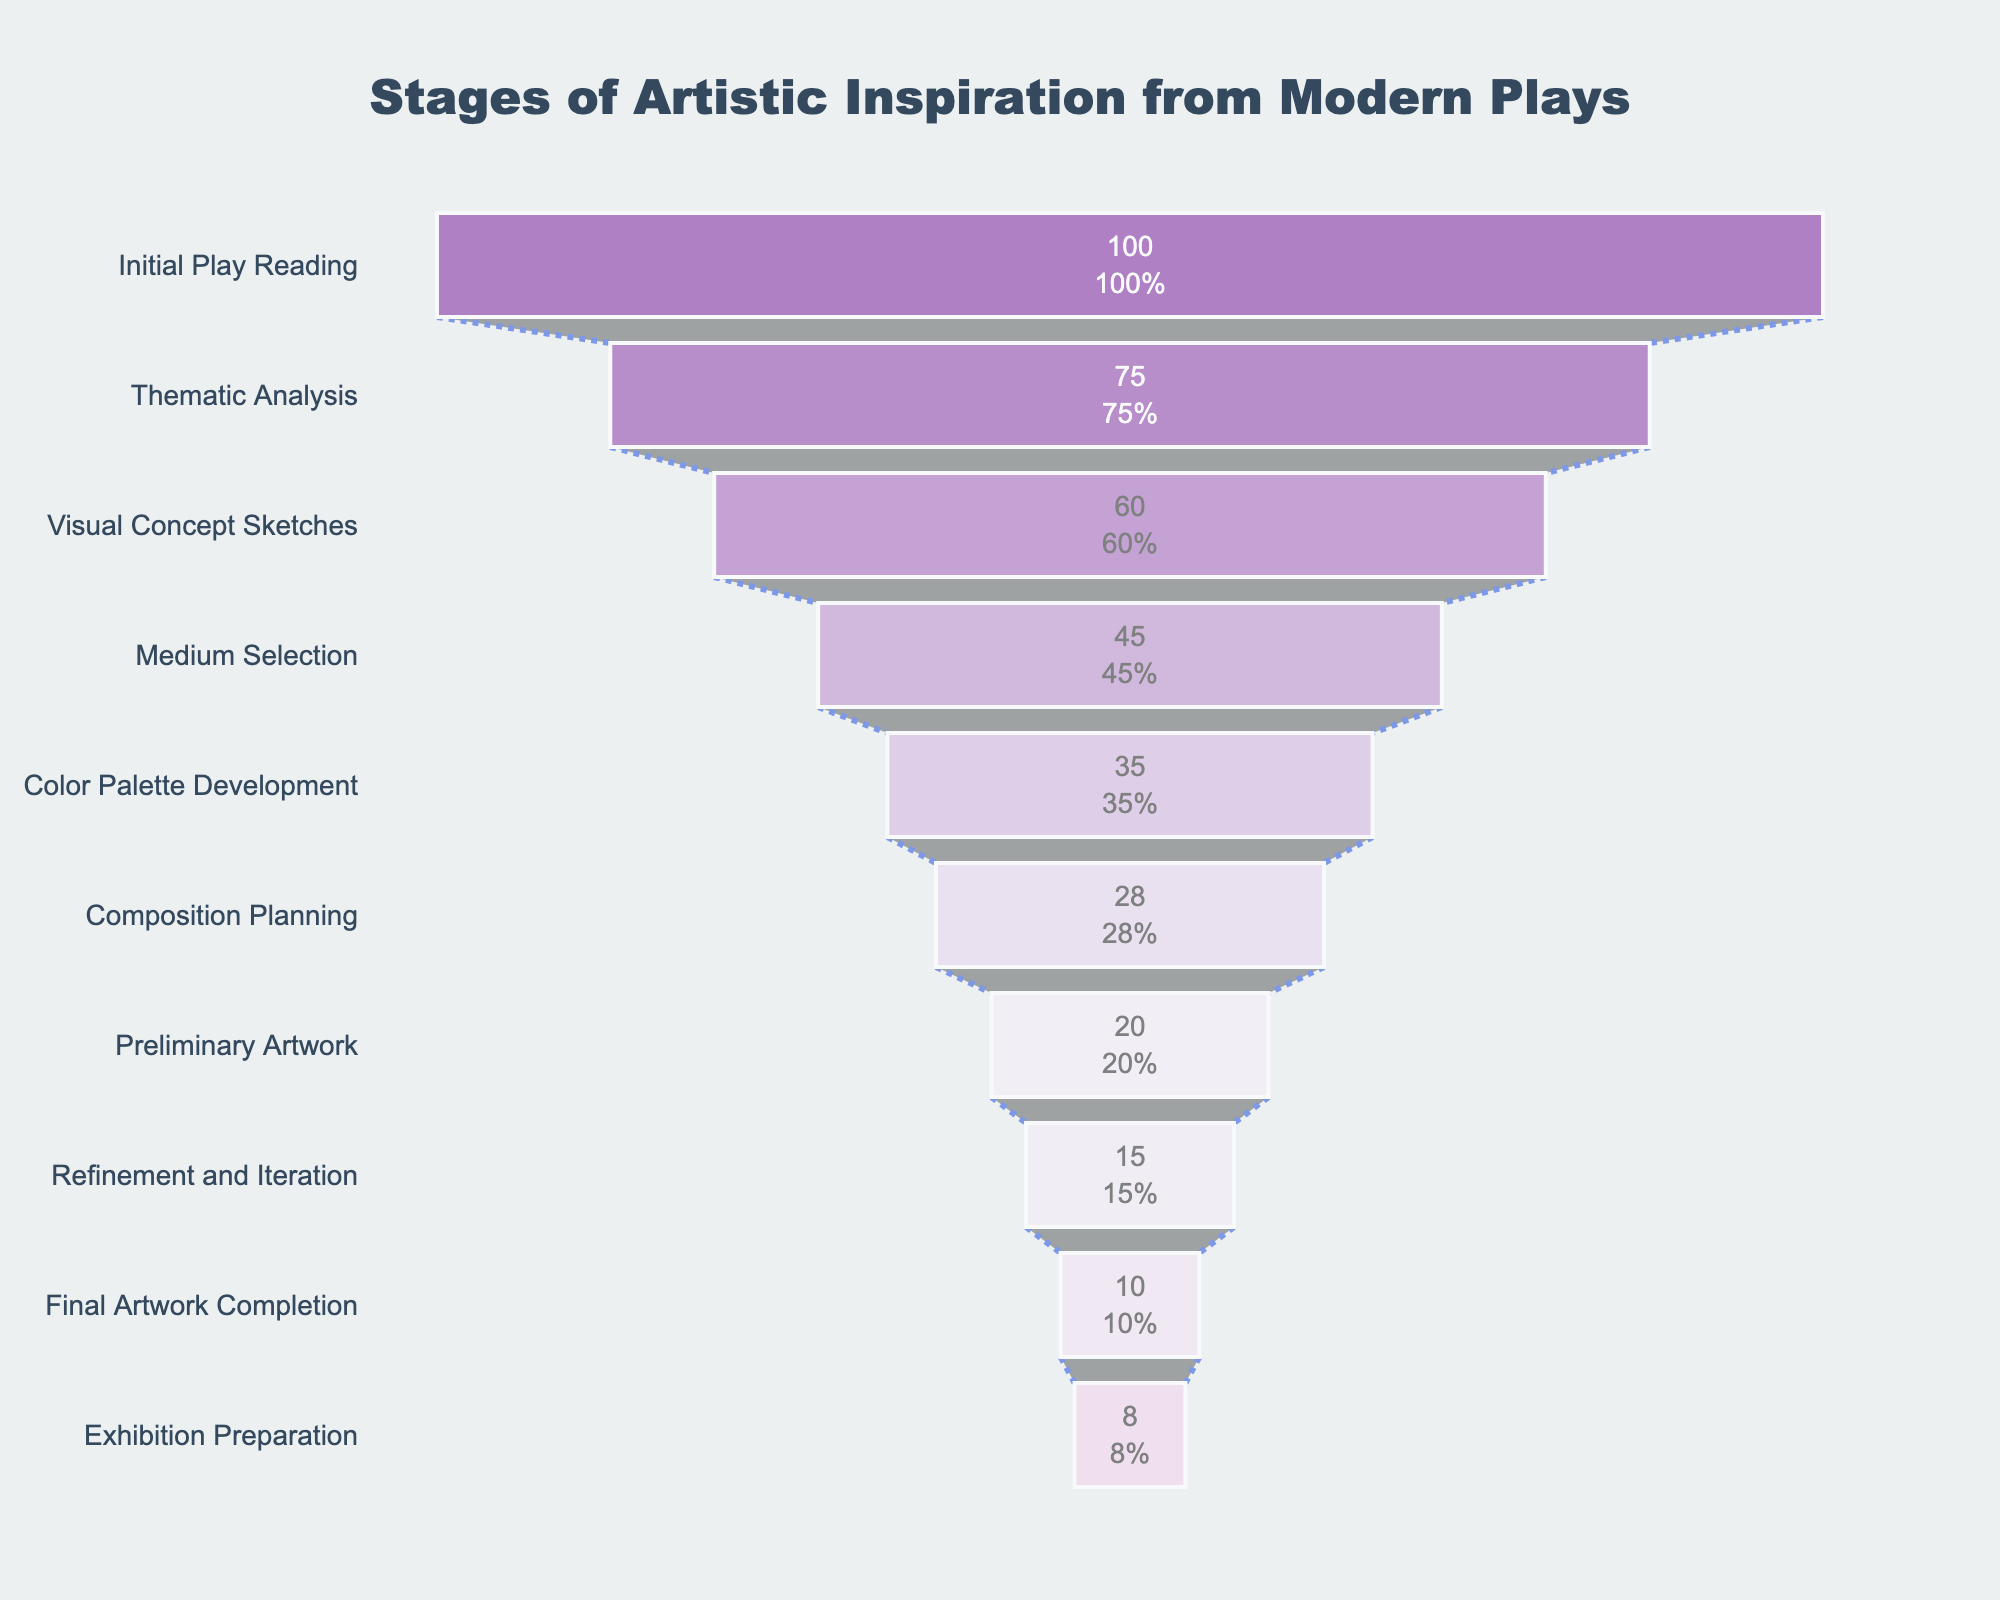What's the title of the figure? The title of a chart is typically found at the top and in larger font than the rest of the text. In this case, it's a descriptive title indicating what the chart is about.
Answer: Stages of Artistic Inspiration from Modern Plays How many stages are illustrated in the funnel chart? To find the number of stages, count the distinct stages listed along the vertical axis of the funnel. Each stage corresponds to one row in the data.
Answer: 10 What is the color assigned to the 'Thematic Analysis' stage? Each stage is colored differently. 'Thematic Analysis' corresponds to the second row in the data and is color-coded. We can identify its color from the chart's color progression.
Answer: Light Purple (#9B59B6) How many ideas are lost between the 'Initial Play Reading' and 'Final Artwork Completion' stages? Subtract the number of ideas at the 'Final Artwork Completion' stage from the number at the 'Initial Play Reading' stage. This will show the total reduction in ideas through the stages.
Answer: 90 How many stages have fewer than 20 ideas? Identify the stages where the number of ideas is less than 20. Count how many such stages exist.
Answer: 3 What percentage of initial ideas remain at the 'Medium Selection' stage? To find this percentage, take the number of ideas at 'Medium Selection' stage and divide it by the number of initial ideas at 'Initial Play Reading' stage, then multiply by 100.
Answer: 45% Which stage experiences the largest drop in the number of ideas? Calculate the differences in the number of ideas between successive stages and identify which drop is the largest.
Answer: Initial Play Reading to Thematic Analysis What is the relationship between the 'Preliminary Artwork' and 'Final Artwork Completion' stages in terms of idea reduction? Compare the number of ideas in both stages. Calculate the difference to see how many ideas are reduced.
Answer: 10 What happens to the ideas as they go from 'Visual Concept Sketches' to 'Composition Planning'? Identify the number of ideas at 'Visual Concept Sketches' and 'Composition Planning' stages and subtract to understand the decrease.
Answer: 32 What is the overall theme depicted by the succession of stages in the funnel chart? Considering the names of the stages, observe how each step likely builds on the previous one, from reading a play to preparing for exhibition, summarizing the creative process.
Answer: Process of artistic development 